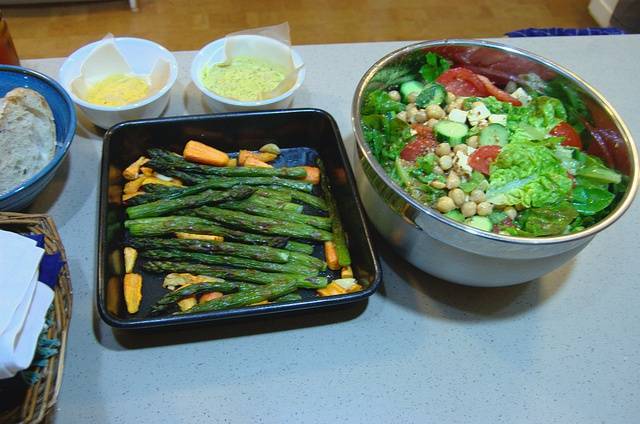Describe the objects in this image and their specific colors. I can see dining table in lightblue, black, and darkgray tones, bowl in black, gray, and darkgreen tones, bowl in black, lightgray, lightblue, and khaki tones, bowl in black, khaki, lightblue, and lightgreen tones, and bowl in black, blue, and navy tones in this image. 